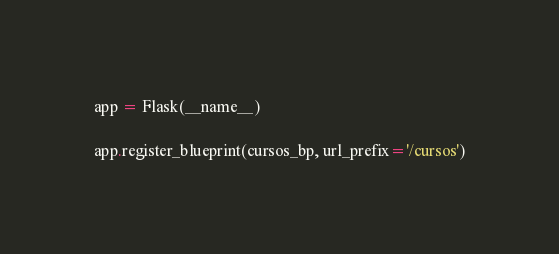Convert code to text. <code><loc_0><loc_0><loc_500><loc_500><_Python_>
app = Flask(__name__)

app.register_blueprint(cursos_bp, url_prefix='/cursos')
</code> 